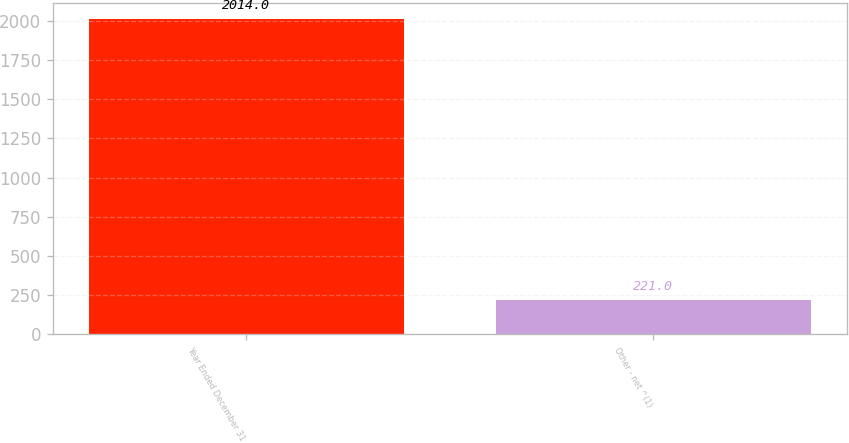Convert chart to OTSL. <chart><loc_0><loc_0><loc_500><loc_500><bar_chart><fcel>Year Ended December 31<fcel>Other - net ^(1)<nl><fcel>2014<fcel>221<nl></chart> 